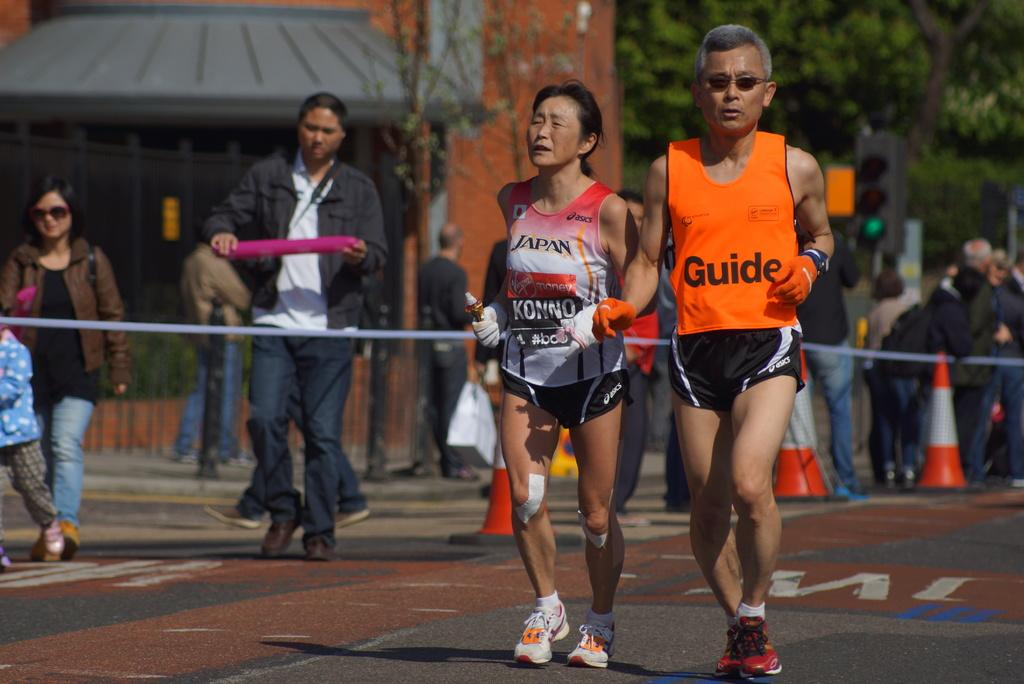<image>
Offer a succinct explanation of the picture presented. A photo of a race with the a man having the word Guide on his jersey. 